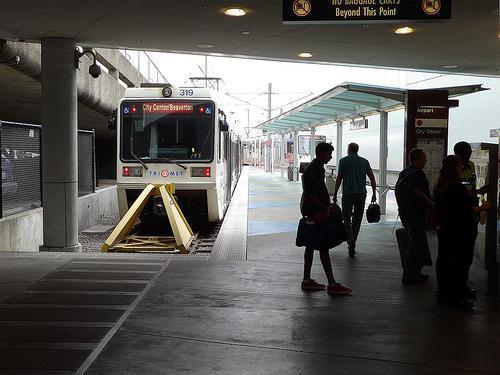How many travelers are present?
Give a very brief answer. 5. 